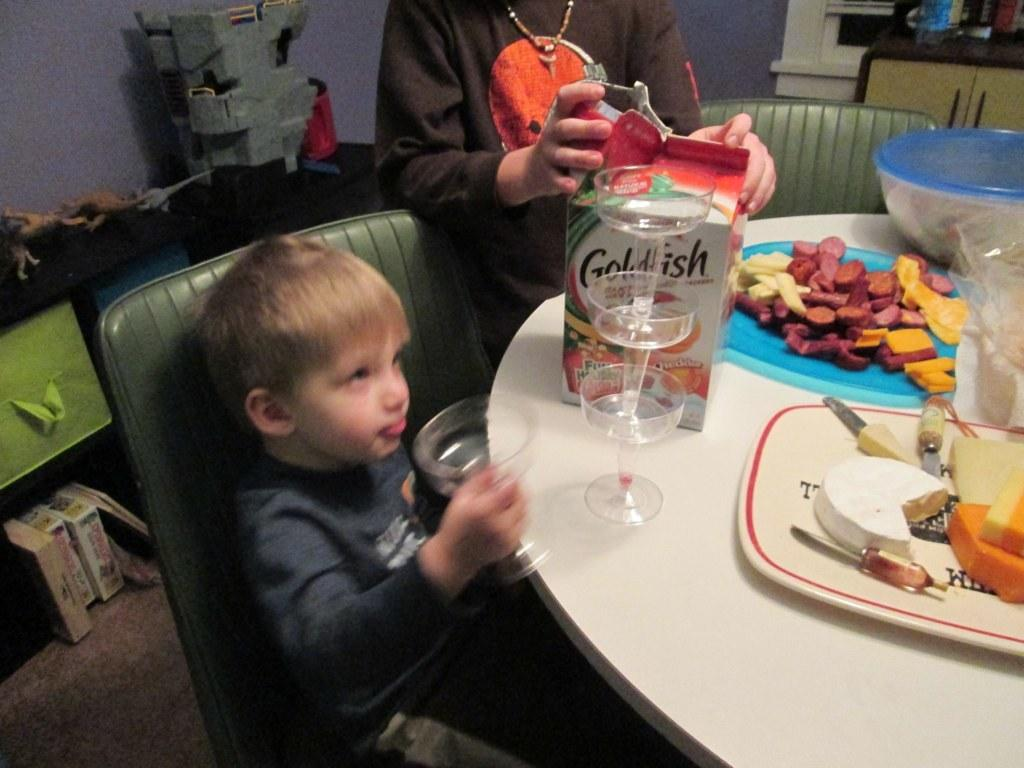What is on the table in the image? There is a tray and a bowl on the table. What else can be seen on the table? There are things on the table, but the specific items are not mentioned in the facts. What is the kid doing in the image? The kid is sitting on a chair and holding a glass. What is under the table in the image? There are books under the table. Who is standing beside the chair in the image? A person is standing beside the chair. How many kittens are playing on the edge of the table in the image? There are no kittens present in the image. What is the birth date of the person standing beside the chair in the image? The facts provided do not mention the person's birth date, so it cannot be determined from the image. 